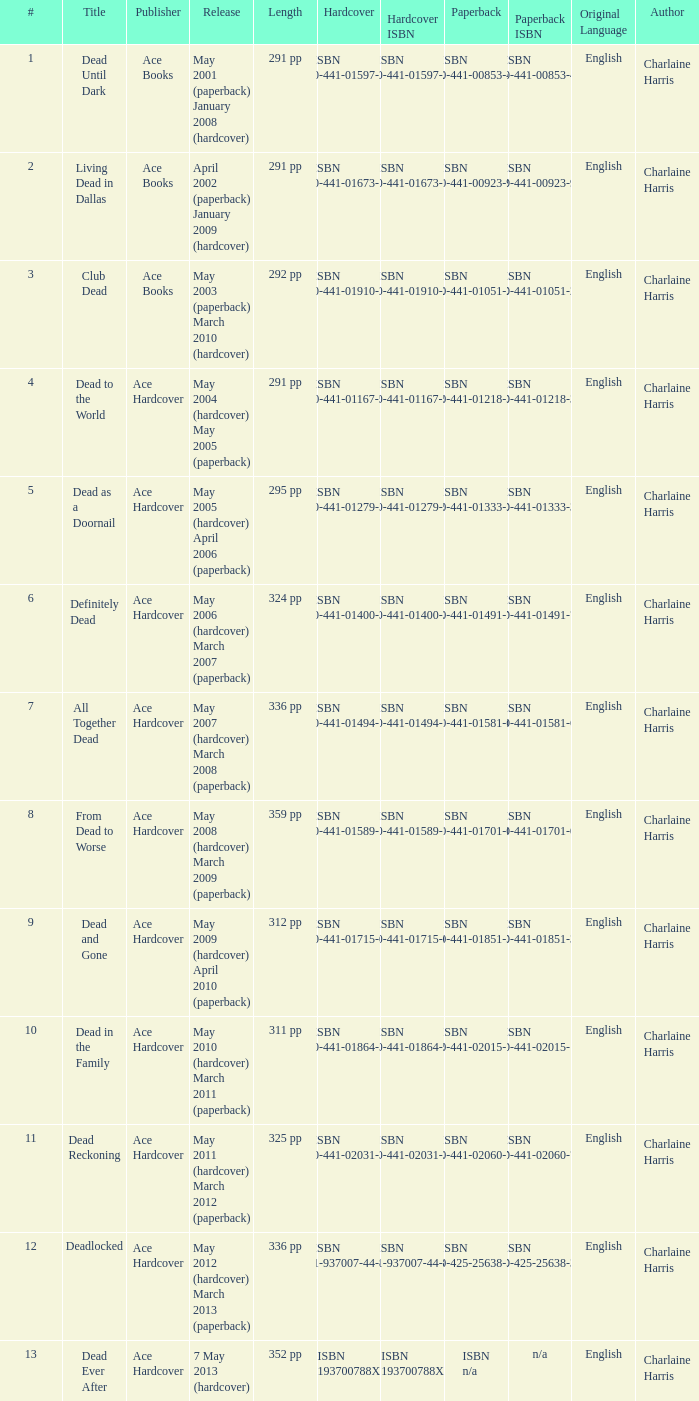Isbn 0-441-01400-3 is book number? 6.0. 